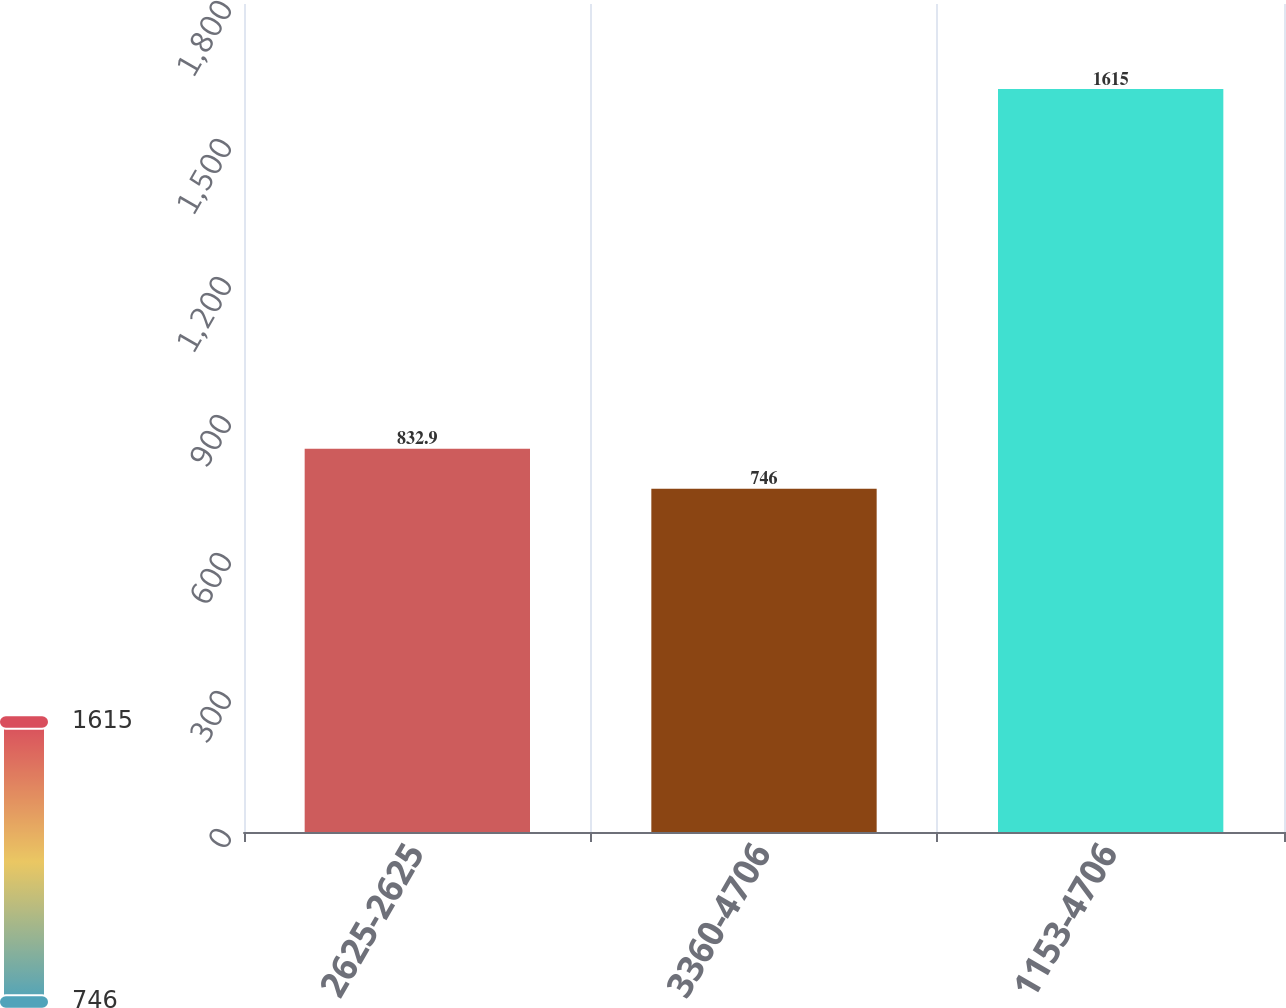Convert chart. <chart><loc_0><loc_0><loc_500><loc_500><bar_chart><fcel>2625-2625<fcel>3360-4706<fcel>1153-4706<nl><fcel>832.9<fcel>746<fcel>1615<nl></chart> 